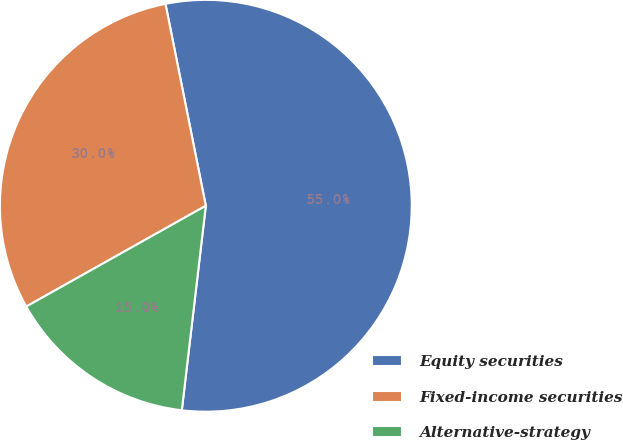<chart> <loc_0><loc_0><loc_500><loc_500><pie_chart><fcel>Equity securities<fcel>Fixed-income securities<fcel>Alternative-strategy<nl><fcel>55.0%<fcel>30.0%<fcel>15.0%<nl></chart> 